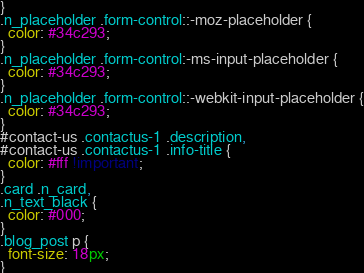<code> <loc_0><loc_0><loc_500><loc_500><_CSS_>}
.n_placeholder .form-control::-moz-placeholder {
  color: #34c293;
}
.n_placeholder .form-control:-ms-input-placeholder {
  color: #34c293;
}
.n_placeholder .form-control::-webkit-input-placeholder {
  color: #34c293;
}
#contact-us .contactus-1 .description,
#contact-us .contactus-1 .info-title {
  color: #fff !important;
}
.card .n_card,
.n_text_black {
  color: #000;
}
.blog_post p {
  font-size: 18px;
}
</code> 